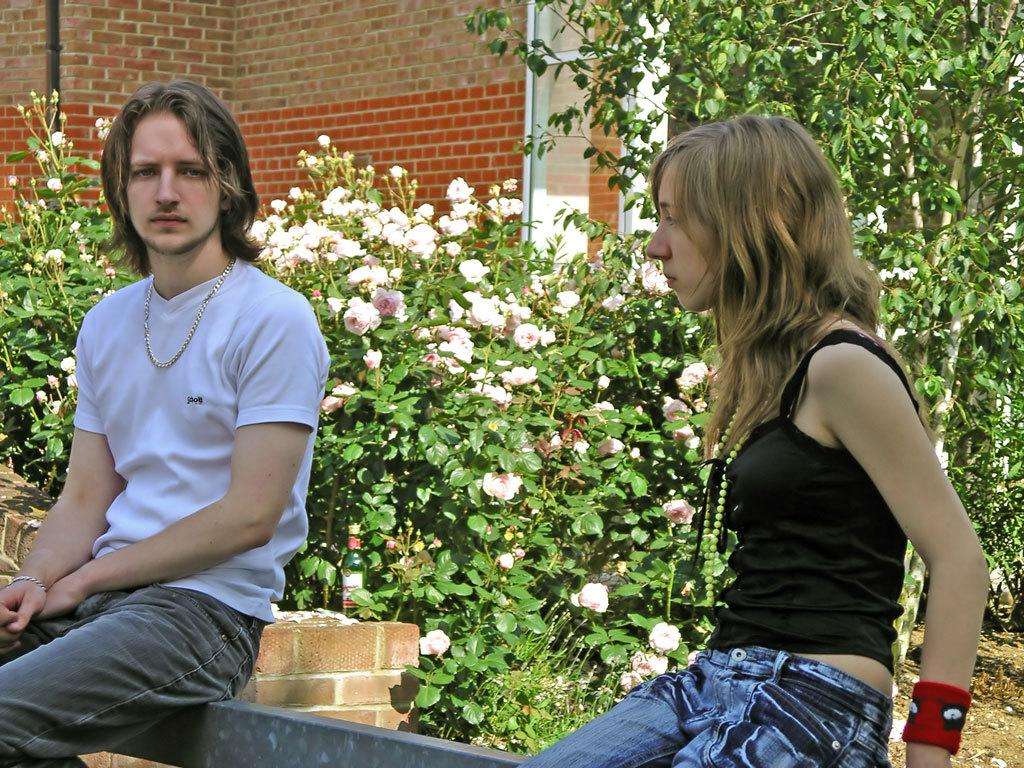How many people are in the image? There are persons in the image, but the exact number is not specified. What are the persons wearing? The persons are wearing clothes. What are the persons doing in the image? The persons are sitting on a wall. What can be seen in the middle of the image? There are plants in the middle of the image. What is visible at the top of the image? There is another wall at the top of the image. What arithmetic problem is the grandmother solving in the image? There is no grandmother present in the image, and no arithmetic problem is being solved. What type of growth can be observed in the plants in the image? The image does not show any specific growth in the plants, only their presence. 